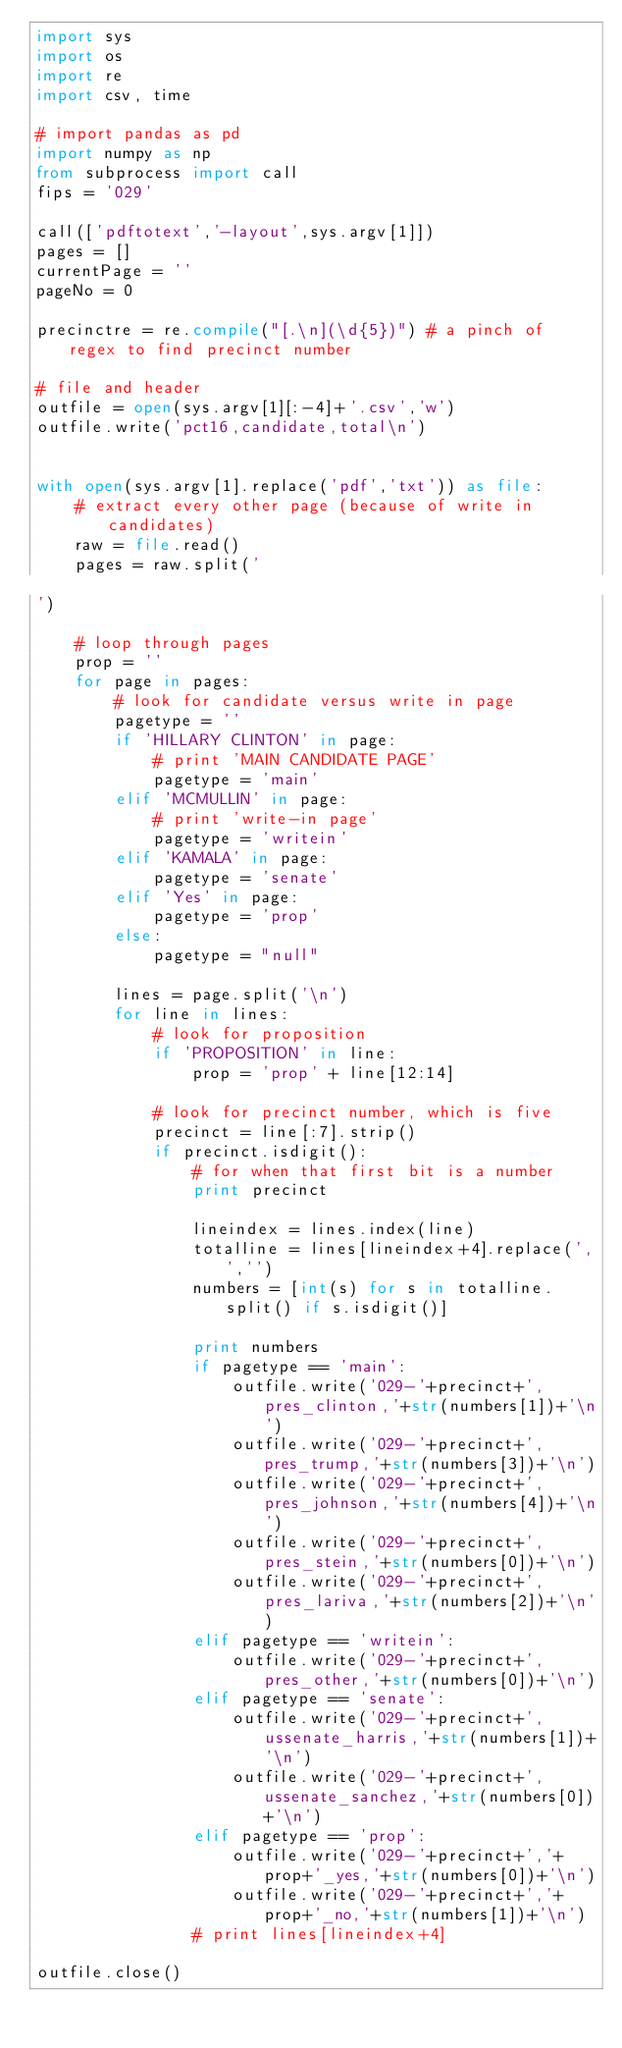<code> <loc_0><loc_0><loc_500><loc_500><_Python_>import sys
import os
import re
import csv, time

# import pandas as pd
import numpy as np
from subprocess import call
fips = '029'

call(['pdftotext','-layout',sys.argv[1]])
pages = []
currentPage = ''
pageNo = 0

precinctre = re.compile("[.\n](\d{5})") # a pinch of regex to find precinct number

# file and header
outfile = open(sys.argv[1][:-4]+'.csv','w')
outfile.write('pct16,candidate,total\n')


with open(sys.argv[1].replace('pdf','txt')) as file:
	# extract every other page (because of write in candidates)
	raw = file.read()
	pages = raw.split('')

	# loop through pages
	prop = ''
	for page in pages:
		# look for candidate versus write in page
		pagetype = ''
		if 'HILLARY CLINTON' in page:
			# print 'MAIN CANDIDATE PAGE'
			pagetype = 'main'
		elif 'MCMULLIN' in page:
			# print 'write-in page'
			pagetype = 'writein'
		elif 'KAMALA' in page:
			pagetype = 'senate'
		elif 'Yes' in page:
			pagetype = 'prop'
		else:
			pagetype = "null"

		lines = page.split('\n')
		for line in lines:
			# look for proposition
			if 'PROPOSITION' in line:
				prop = 'prop' + line[12:14]

			# look for precinct number, which is five 
			precinct = line[:7].strip()
			if precinct.isdigit():
				# for when that first bit is a number
				print precinct

				lineindex = lines.index(line)
				totalline = lines[lineindex+4].replace(',','')
				numbers = [int(s) for s in totalline.split() if s.isdigit()]

				print numbers
				if pagetype == 'main':
					outfile.write('029-'+precinct+',pres_clinton,'+str(numbers[1])+'\n')
					outfile.write('029-'+precinct+',pres_trump,'+str(numbers[3])+'\n')
					outfile.write('029-'+precinct+',pres_johnson,'+str(numbers[4])+'\n')
					outfile.write('029-'+precinct+',pres_stein,'+str(numbers[0])+'\n')
					outfile.write('029-'+precinct+',pres_lariva,'+str(numbers[2])+'\n')
				elif pagetype == 'writein':
					outfile.write('029-'+precinct+',pres_other,'+str(numbers[0])+'\n')
				elif pagetype == 'senate':
					outfile.write('029-'+precinct+',ussenate_harris,'+str(numbers[1])+'\n')
					outfile.write('029-'+precinct+',ussenate_sanchez,'+str(numbers[0])+'\n')
				elif pagetype == 'prop':
					outfile.write('029-'+precinct+','+prop+'_yes,'+str(numbers[0])+'\n')
					outfile.write('029-'+precinct+','+prop+'_no,'+str(numbers[1])+'\n')
				# print lines[lineindex+4]

outfile.close()</code> 